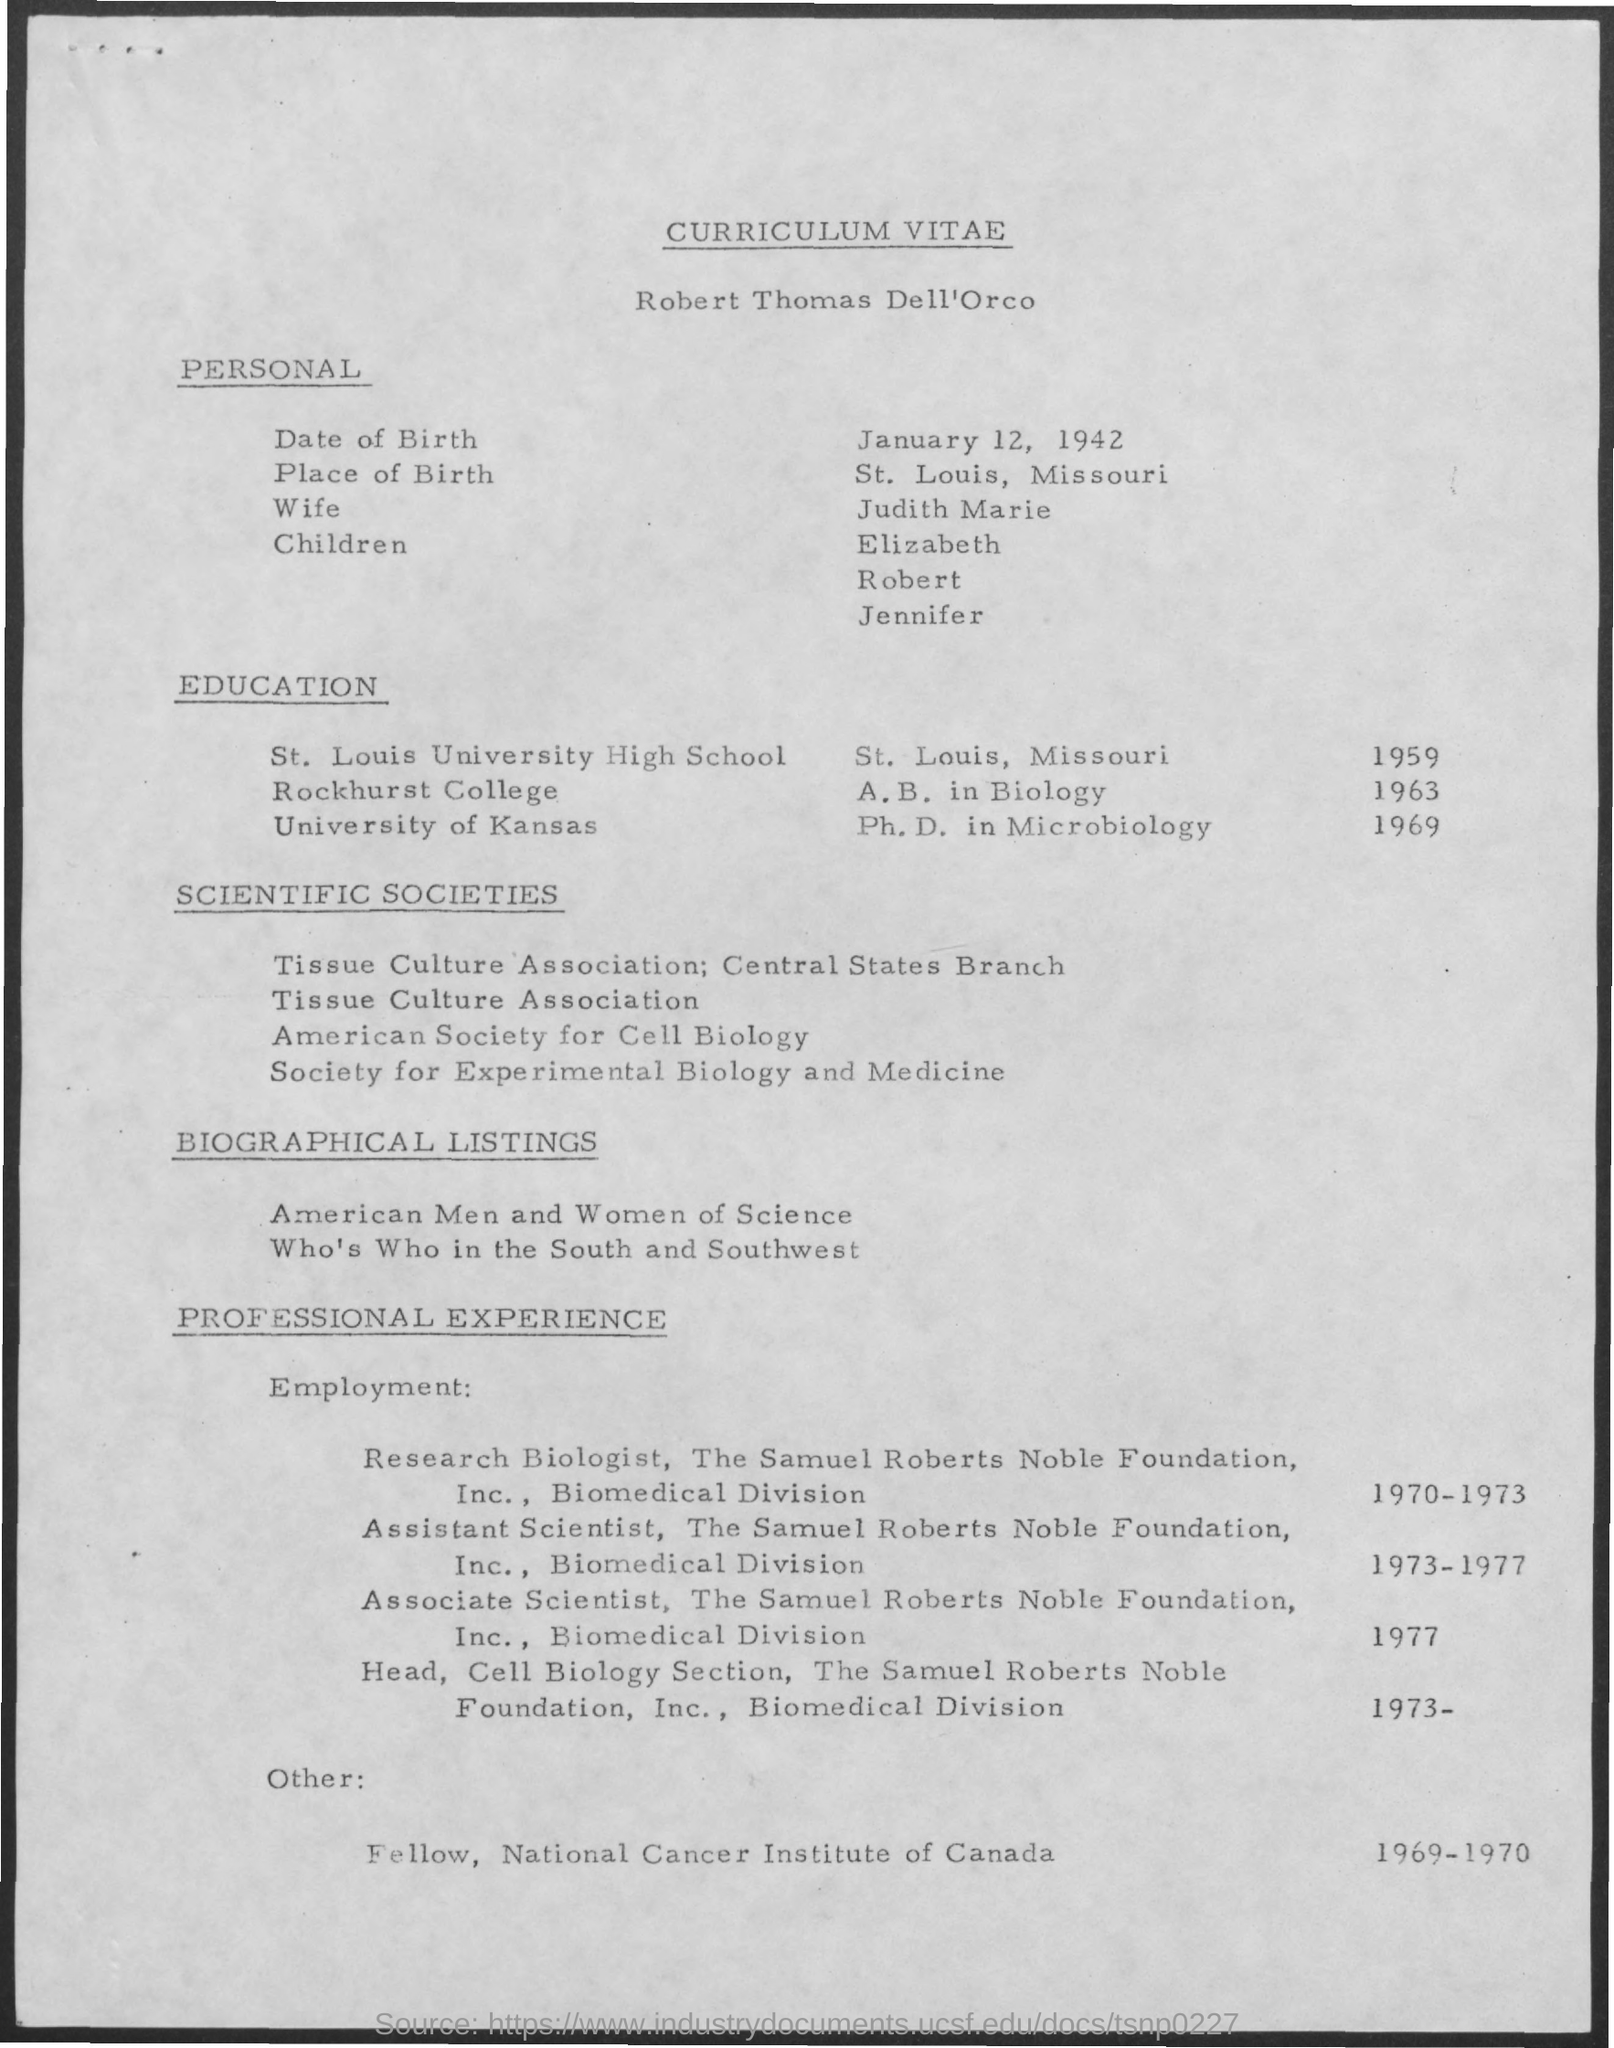What is the Title of the document?
Provide a succinct answer. Curriculum Vitae. What is the Date of Birth?
Give a very brief answer. January 12, 1942. What is the Place of Birth?
Your response must be concise. St. Louis, Missouri. Who is the wife?
Your response must be concise. Judith Marie. 